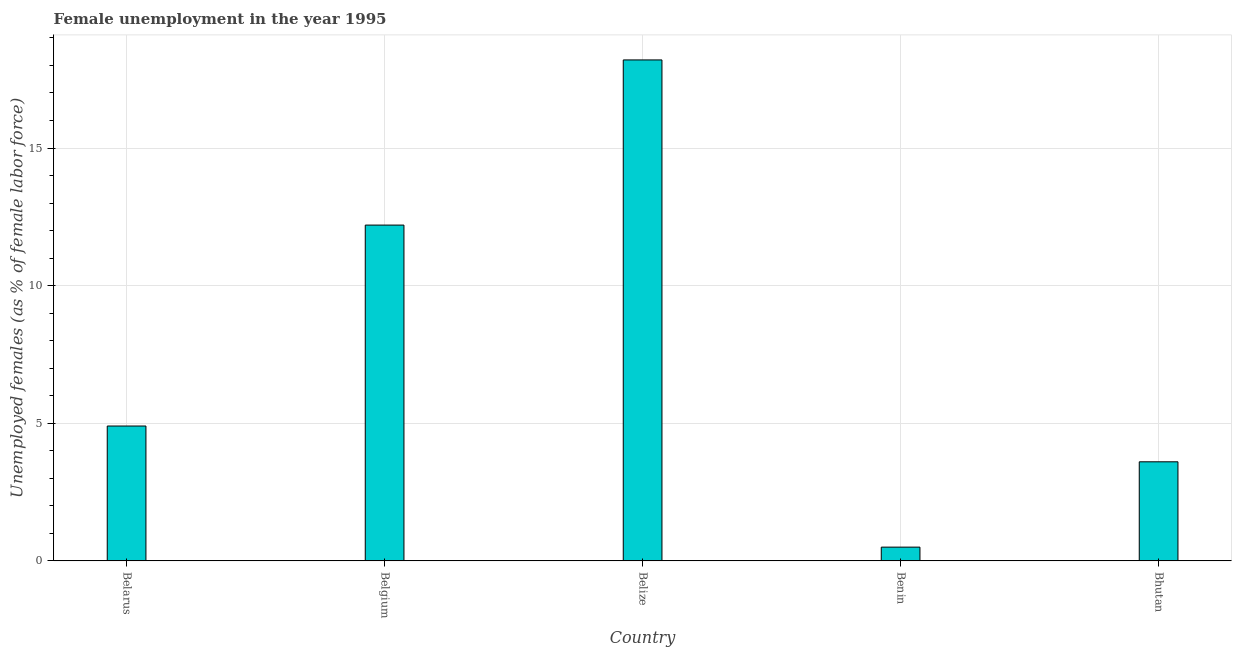Does the graph contain any zero values?
Make the answer very short. No. What is the title of the graph?
Your answer should be very brief. Female unemployment in the year 1995. What is the label or title of the Y-axis?
Keep it short and to the point. Unemployed females (as % of female labor force). Across all countries, what is the maximum unemployed females population?
Your response must be concise. 18.2. Across all countries, what is the minimum unemployed females population?
Your answer should be compact. 0.5. In which country was the unemployed females population maximum?
Provide a short and direct response. Belize. In which country was the unemployed females population minimum?
Offer a very short reply. Benin. What is the sum of the unemployed females population?
Keep it short and to the point. 39.4. What is the difference between the unemployed females population in Belgium and Belize?
Your response must be concise. -6. What is the average unemployed females population per country?
Your answer should be compact. 7.88. What is the median unemployed females population?
Your answer should be very brief. 4.9. In how many countries, is the unemployed females population greater than 10 %?
Provide a short and direct response. 2. What is the ratio of the unemployed females population in Belgium to that in Benin?
Offer a very short reply. 24.4. What is the difference between the highest and the second highest unemployed females population?
Keep it short and to the point. 6. Is the sum of the unemployed females population in Belize and Benin greater than the maximum unemployed females population across all countries?
Offer a very short reply. Yes. How many bars are there?
Offer a terse response. 5. Are all the bars in the graph horizontal?
Keep it short and to the point. No. How many countries are there in the graph?
Ensure brevity in your answer.  5. What is the Unemployed females (as % of female labor force) of Belarus?
Make the answer very short. 4.9. What is the Unemployed females (as % of female labor force) of Belgium?
Offer a very short reply. 12.2. What is the Unemployed females (as % of female labor force) of Belize?
Make the answer very short. 18.2. What is the Unemployed females (as % of female labor force) in Benin?
Offer a very short reply. 0.5. What is the Unemployed females (as % of female labor force) of Bhutan?
Your answer should be very brief. 3.6. What is the difference between the Unemployed females (as % of female labor force) in Belarus and Belgium?
Offer a terse response. -7.3. What is the difference between the Unemployed females (as % of female labor force) in Belarus and Benin?
Keep it short and to the point. 4.4. What is the difference between the Unemployed females (as % of female labor force) in Belgium and Belize?
Give a very brief answer. -6. What is the difference between the Unemployed females (as % of female labor force) in Belgium and Bhutan?
Your answer should be very brief. 8.6. What is the difference between the Unemployed females (as % of female labor force) in Belize and Bhutan?
Offer a very short reply. 14.6. What is the difference between the Unemployed females (as % of female labor force) in Benin and Bhutan?
Keep it short and to the point. -3.1. What is the ratio of the Unemployed females (as % of female labor force) in Belarus to that in Belgium?
Your response must be concise. 0.4. What is the ratio of the Unemployed females (as % of female labor force) in Belarus to that in Belize?
Offer a terse response. 0.27. What is the ratio of the Unemployed females (as % of female labor force) in Belarus to that in Bhutan?
Provide a short and direct response. 1.36. What is the ratio of the Unemployed females (as % of female labor force) in Belgium to that in Belize?
Make the answer very short. 0.67. What is the ratio of the Unemployed females (as % of female labor force) in Belgium to that in Benin?
Make the answer very short. 24.4. What is the ratio of the Unemployed females (as % of female labor force) in Belgium to that in Bhutan?
Your response must be concise. 3.39. What is the ratio of the Unemployed females (as % of female labor force) in Belize to that in Benin?
Offer a terse response. 36.4. What is the ratio of the Unemployed females (as % of female labor force) in Belize to that in Bhutan?
Your answer should be compact. 5.06. What is the ratio of the Unemployed females (as % of female labor force) in Benin to that in Bhutan?
Give a very brief answer. 0.14. 